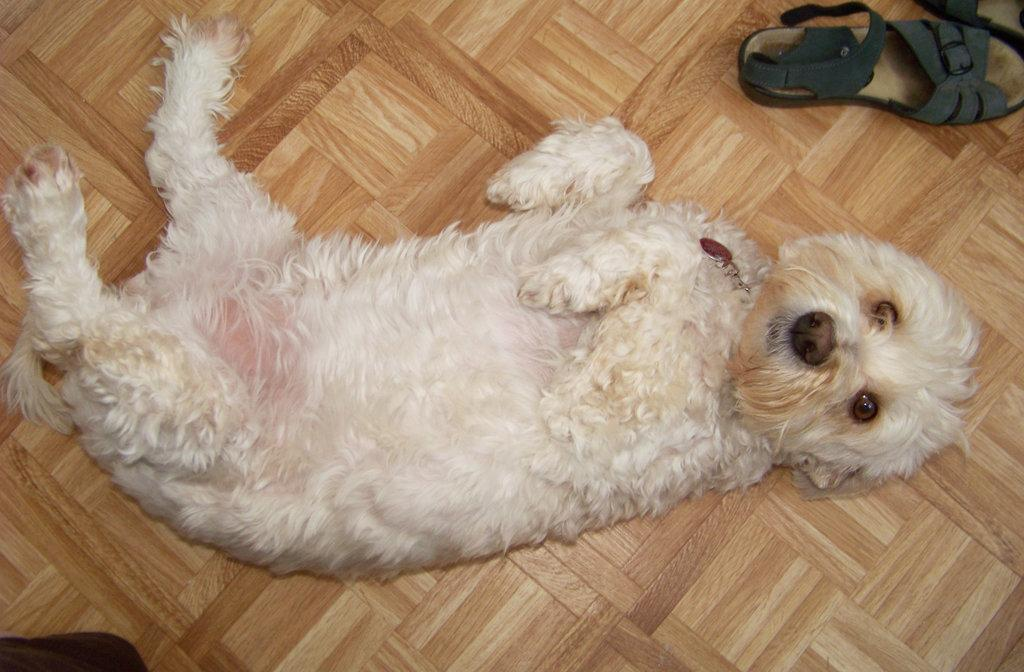What type of animal is in the image? There is a dog in the image. Where is the dog located? The dog is on the floor. Can you describe any other objects in the image? There is a slipper in the top right corner of the image. What type of cheese is the dog eating in the image? There is no cheese present in the image; the dog is simply on the floor. 